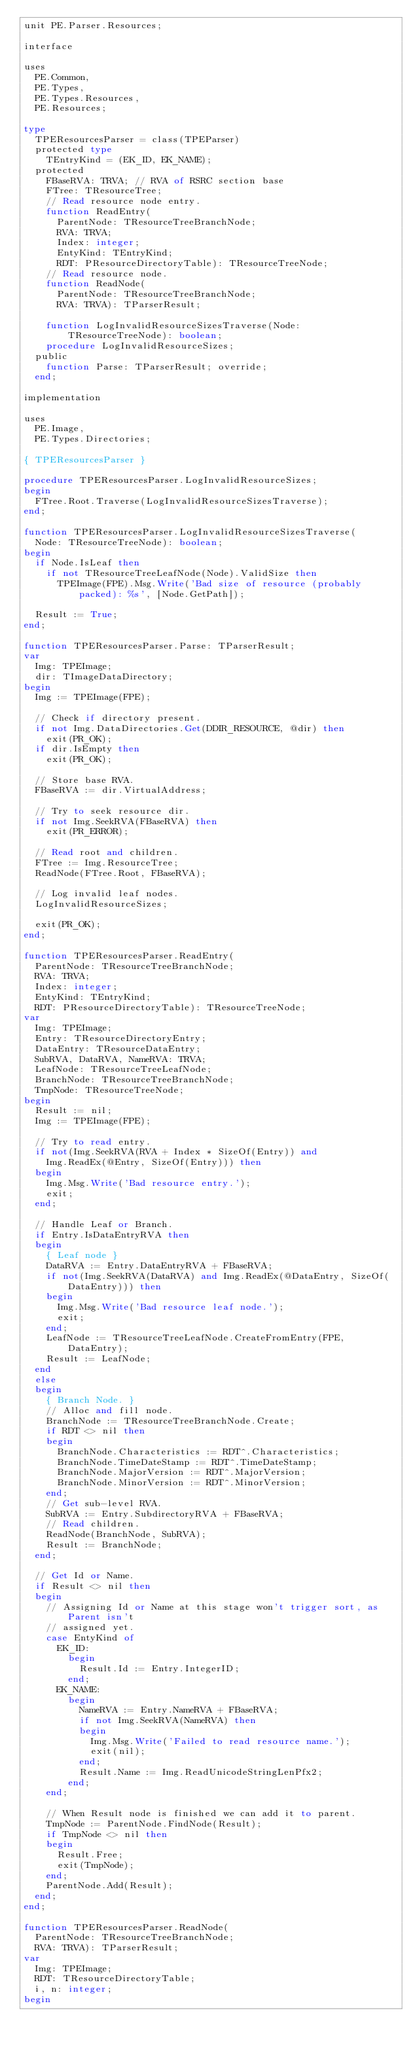<code> <loc_0><loc_0><loc_500><loc_500><_Pascal_>unit PE.Parser.Resources;

interface

uses
  PE.Common,
  PE.Types,
  PE.Types.Resources,
  PE.Resources;

type
  TPEResourcesParser = class(TPEParser)
  protected type
    TEntryKind = (EK_ID, EK_NAME);
  protected
    FBaseRVA: TRVA; // RVA of RSRC section base
    FTree: TResourceTree;
    // Read resource node entry.
    function ReadEntry(
      ParentNode: TResourceTreeBranchNode;
      RVA: TRVA;
      Index: integer;
      EntyKind: TEntryKind;
      RDT: PResourceDirectoryTable): TResourceTreeNode;
    // Read resource node.
    function ReadNode(
      ParentNode: TResourceTreeBranchNode;
      RVA: TRVA): TParserResult;

    function LogInvalidResourceSizesTraverse(Node: TResourceTreeNode): boolean;
    procedure LogInvalidResourceSizes;
  public
    function Parse: TParserResult; override;
  end;

implementation

uses
  PE.Image,
  PE.Types.Directories;

{ TPEResourcesParser }

procedure TPEResourcesParser.LogInvalidResourceSizes;
begin
  FTree.Root.Traverse(LogInvalidResourceSizesTraverse);
end;

function TPEResourcesParser.LogInvalidResourceSizesTraverse(
  Node: TResourceTreeNode): boolean;
begin
  if Node.IsLeaf then
    if not TResourceTreeLeafNode(Node).ValidSize then
      TPEImage(FPE).Msg.Write('Bad size of resource (probably packed): %s', [Node.GetPath]);

  Result := True;
end;

function TPEResourcesParser.Parse: TParserResult;
var
  Img: TPEImage;
  dir: TImageDataDirectory;
begin
  Img := TPEImage(FPE);

  // Check if directory present.
  if not Img.DataDirectories.Get(DDIR_RESOURCE, @dir) then
    exit(PR_OK);
  if dir.IsEmpty then
    exit(PR_OK);

  // Store base RVA.
  FBaseRVA := dir.VirtualAddress;

  // Try to seek resource dir.
  if not Img.SeekRVA(FBaseRVA) then
    exit(PR_ERROR);

  // Read root and children.
  FTree := Img.ResourceTree;
  ReadNode(FTree.Root, FBaseRVA);

  // Log invalid leaf nodes.
  LogInvalidResourceSizes;

  exit(PR_OK);
end;

function TPEResourcesParser.ReadEntry(
  ParentNode: TResourceTreeBranchNode;
  RVA: TRVA;
  Index: integer;
  EntyKind: TEntryKind;
  RDT: PResourceDirectoryTable): TResourceTreeNode;
var
  Img: TPEImage;
  Entry: TResourceDirectoryEntry;
  DataEntry: TResourceDataEntry;
  SubRVA, DataRVA, NameRVA: TRVA;
  LeafNode: TResourceTreeLeafNode;
  BranchNode: TResourceTreeBranchNode;
  TmpNode: TResourceTreeNode;
begin
  Result := nil;
  Img := TPEImage(FPE);

  // Try to read entry.
  if not(Img.SeekRVA(RVA + Index * SizeOf(Entry)) and
    Img.ReadEx(@Entry, SizeOf(Entry))) then
  begin
    Img.Msg.Write('Bad resource entry.');
    exit;
  end;

  // Handle Leaf or Branch.
  if Entry.IsDataEntryRVA then
  begin
    { Leaf node }
    DataRVA := Entry.DataEntryRVA + FBaseRVA;
    if not(Img.SeekRVA(DataRVA) and Img.ReadEx(@DataEntry, SizeOf(DataEntry))) then
    begin
      Img.Msg.Write('Bad resource leaf node.');
      exit;
    end;
    LeafNode := TResourceTreeLeafNode.CreateFromEntry(FPE, DataEntry);
    Result := LeafNode;
  end
  else
  begin
    { Branch Node. }
    // Alloc and fill node.
    BranchNode := TResourceTreeBranchNode.Create;
    if RDT <> nil then
    begin
      BranchNode.Characteristics := RDT^.Characteristics;
      BranchNode.TimeDateStamp := RDT^.TimeDateStamp;
      BranchNode.MajorVersion := RDT^.MajorVersion;
      BranchNode.MinorVersion := RDT^.MinorVersion;
    end;
    // Get sub-level RVA.
    SubRVA := Entry.SubdirectoryRVA + FBaseRVA;
    // Read children.
    ReadNode(BranchNode, SubRVA);
    Result := BranchNode;
  end;

  // Get Id or Name.
  if Result <> nil then
  begin
    // Assigning Id or Name at this stage won't trigger sort, as Parent isn't
    // assigned yet.
    case EntyKind of
      EK_ID:
        begin
          Result.Id := Entry.IntegerID;
        end;
      EK_NAME:
        begin
          NameRVA := Entry.NameRVA + FBaseRVA;
          if not Img.SeekRVA(NameRVA) then
          begin
            Img.Msg.Write('Failed to read resource name.');
            exit(nil);
          end;
          Result.Name := Img.ReadUnicodeStringLenPfx2;
        end;
    end;

    // When Result node is finished we can add it to parent.
    TmpNode := ParentNode.FindNode(Result);
    if TmpNode <> nil then
    begin
      Result.Free;
      exit(TmpNode);
    end;
    ParentNode.Add(Result);
  end;
end;

function TPEResourcesParser.ReadNode(
  ParentNode: TResourceTreeBranchNode;
  RVA: TRVA): TParserResult;
var
  Img: TPEImage;
  RDT: TResourceDirectoryTable;
  i, n: integer;
begin</code> 